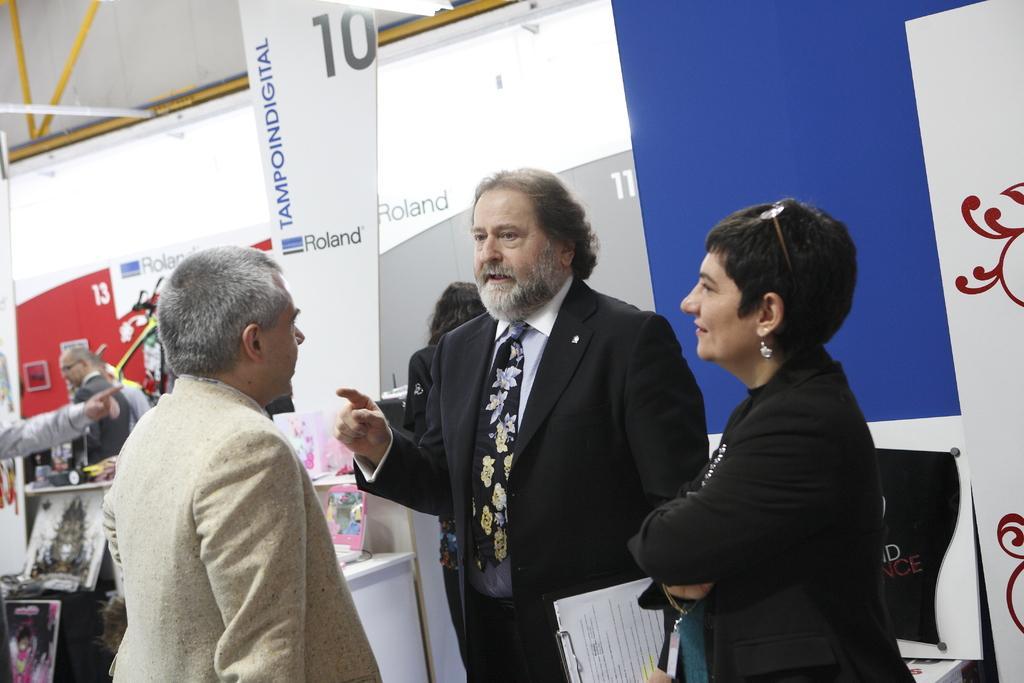Describe this image in one or two sentences. In this image, we can see some people standing and there are some posters. 